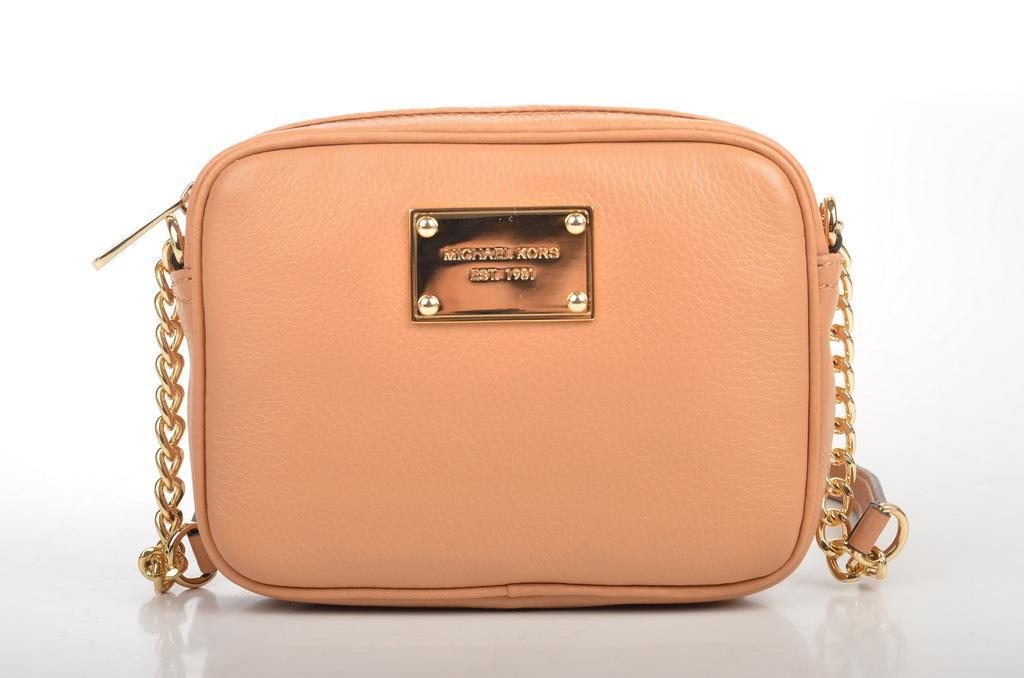In one or two sentences, can you explain what this image depicts? In the image we can see there is peach colour bag and the handle is in golden colour. 